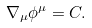<formula> <loc_0><loc_0><loc_500><loc_500>\nabla _ { \mu } \phi ^ { \mu } = C .</formula> 